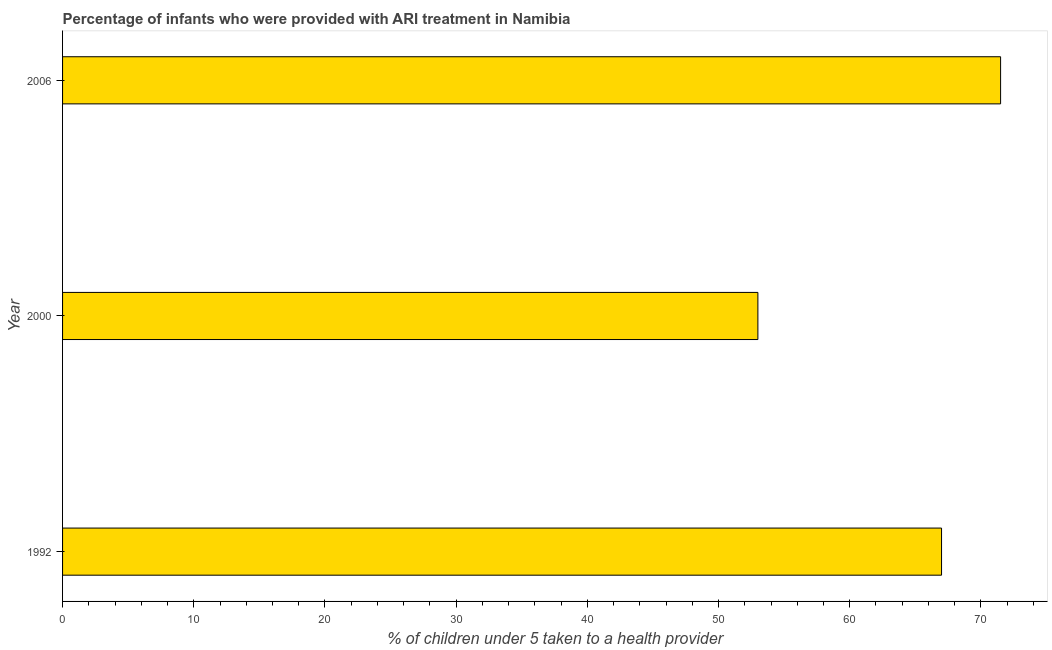Does the graph contain grids?
Offer a very short reply. No. What is the title of the graph?
Your answer should be very brief. Percentage of infants who were provided with ARI treatment in Namibia. What is the label or title of the X-axis?
Give a very brief answer. % of children under 5 taken to a health provider. Across all years, what is the maximum percentage of children who were provided with ari treatment?
Your response must be concise. 71.5. Across all years, what is the minimum percentage of children who were provided with ari treatment?
Your answer should be very brief. 53. In which year was the percentage of children who were provided with ari treatment maximum?
Your answer should be compact. 2006. In which year was the percentage of children who were provided with ari treatment minimum?
Offer a very short reply. 2000. What is the sum of the percentage of children who were provided with ari treatment?
Give a very brief answer. 191.5. What is the difference between the percentage of children who were provided with ari treatment in 2000 and 2006?
Provide a succinct answer. -18.5. What is the average percentage of children who were provided with ari treatment per year?
Your response must be concise. 63.83. In how many years, is the percentage of children who were provided with ari treatment greater than 32 %?
Provide a short and direct response. 3. What is the ratio of the percentage of children who were provided with ari treatment in 2000 to that in 2006?
Your answer should be compact. 0.74. Is the percentage of children who were provided with ari treatment in 1992 less than that in 2006?
Offer a terse response. Yes. What is the difference between the highest and the second highest percentage of children who were provided with ari treatment?
Make the answer very short. 4.5. Is the sum of the percentage of children who were provided with ari treatment in 1992 and 2006 greater than the maximum percentage of children who were provided with ari treatment across all years?
Ensure brevity in your answer.  Yes. What is the difference between the highest and the lowest percentage of children who were provided with ari treatment?
Offer a terse response. 18.5. Are all the bars in the graph horizontal?
Provide a short and direct response. Yes. How many years are there in the graph?
Offer a very short reply. 3. Are the values on the major ticks of X-axis written in scientific E-notation?
Offer a very short reply. No. What is the % of children under 5 taken to a health provider of 1992?
Provide a short and direct response. 67. What is the % of children under 5 taken to a health provider of 2006?
Keep it short and to the point. 71.5. What is the difference between the % of children under 5 taken to a health provider in 2000 and 2006?
Your response must be concise. -18.5. What is the ratio of the % of children under 5 taken to a health provider in 1992 to that in 2000?
Offer a very short reply. 1.26. What is the ratio of the % of children under 5 taken to a health provider in 1992 to that in 2006?
Ensure brevity in your answer.  0.94. What is the ratio of the % of children under 5 taken to a health provider in 2000 to that in 2006?
Your answer should be compact. 0.74. 